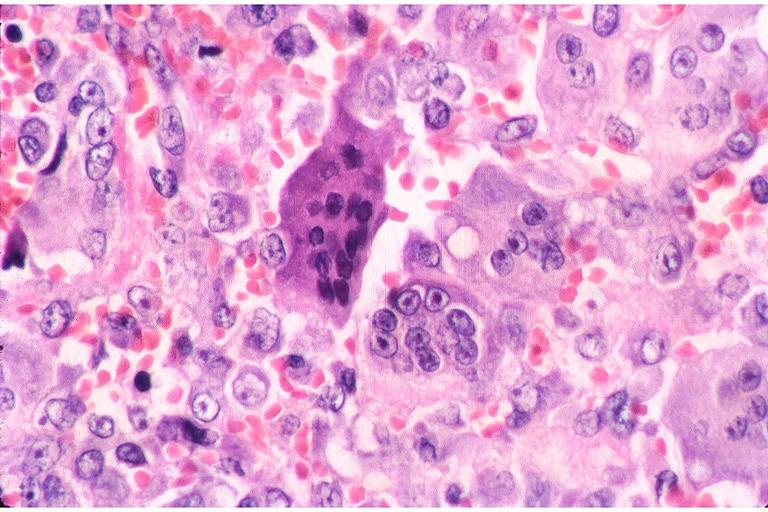s oral present?
Answer the question using a single word or phrase. Yes 